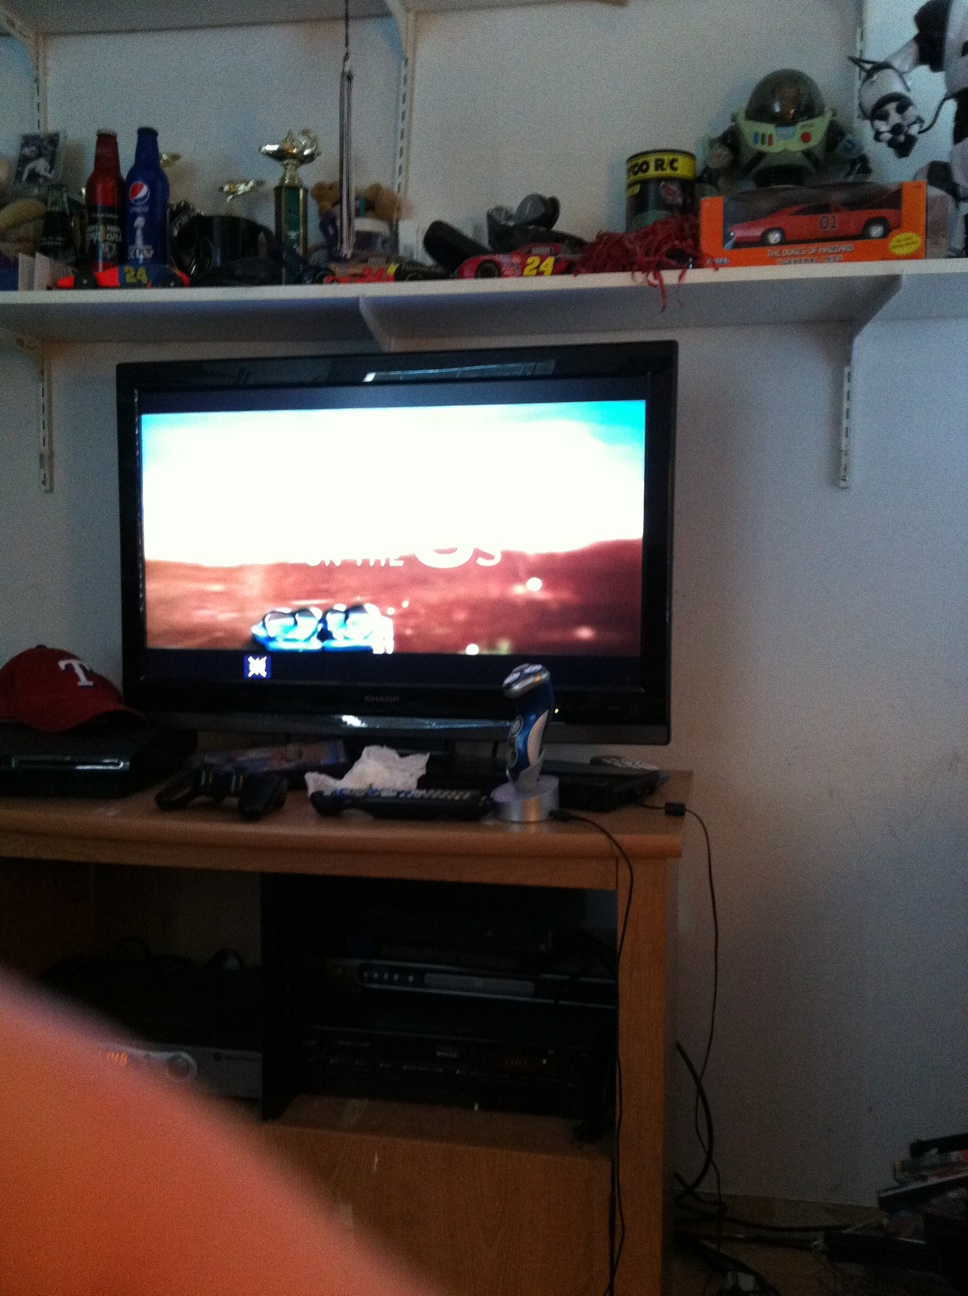What kind of show or content is being shown on the TV screen? The TV screen seems to be showing some kind of promotional content or advert, with bright colors and text that suggests a commercial or trailer. 